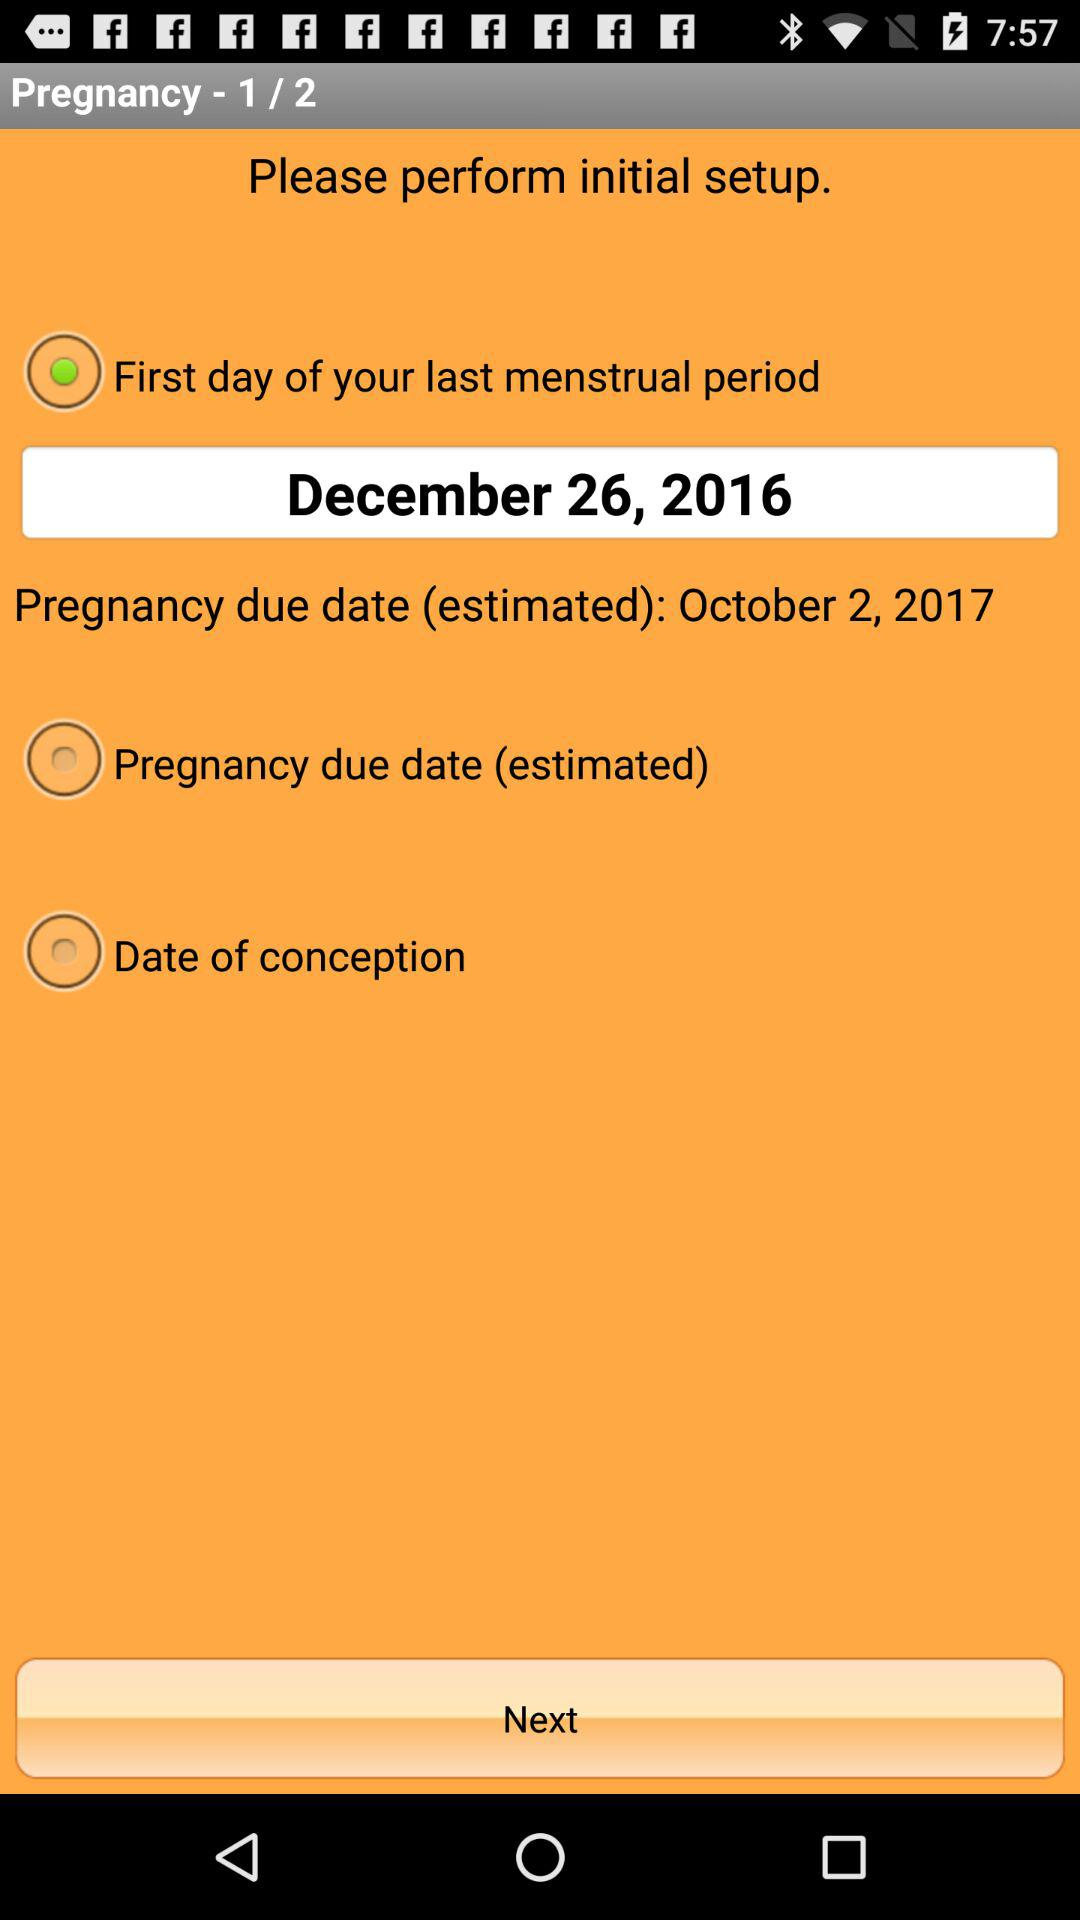Currently, we are on which step? You are on the 1 step. 